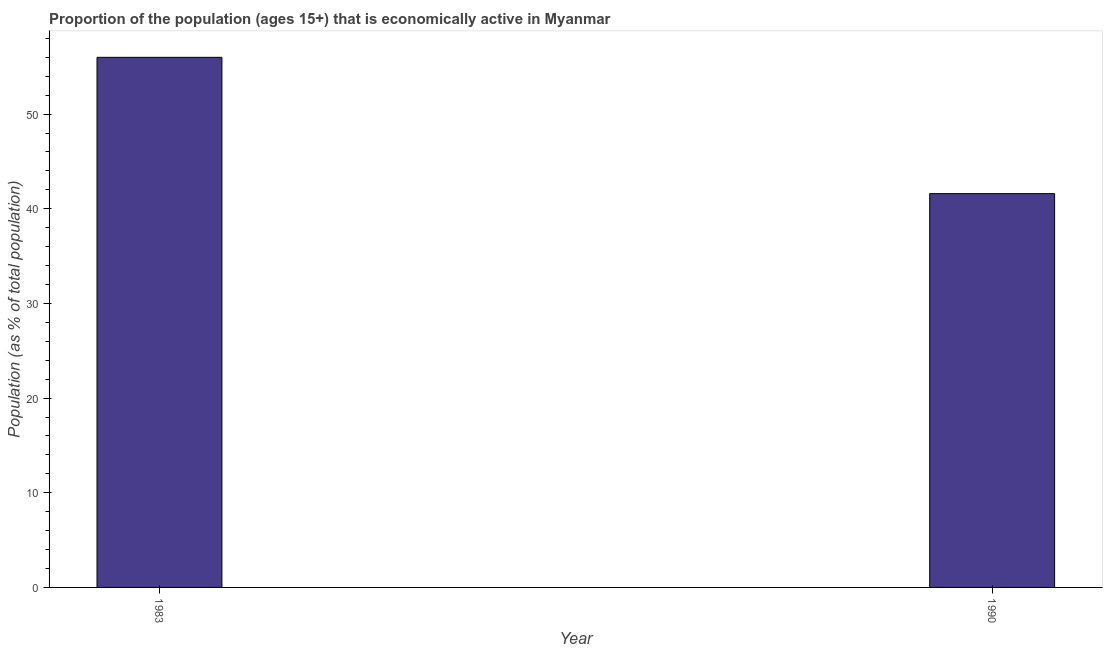Does the graph contain any zero values?
Your response must be concise. No. Does the graph contain grids?
Your answer should be compact. No. What is the title of the graph?
Offer a very short reply. Proportion of the population (ages 15+) that is economically active in Myanmar. What is the label or title of the X-axis?
Keep it short and to the point. Year. What is the label or title of the Y-axis?
Keep it short and to the point. Population (as % of total population). What is the percentage of economically active population in 1990?
Provide a short and direct response. 41.6. Across all years, what is the maximum percentage of economically active population?
Make the answer very short. 56. Across all years, what is the minimum percentage of economically active population?
Keep it short and to the point. 41.6. In which year was the percentage of economically active population maximum?
Offer a very short reply. 1983. What is the sum of the percentage of economically active population?
Ensure brevity in your answer.  97.6. What is the difference between the percentage of economically active population in 1983 and 1990?
Your response must be concise. 14.4. What is the average percentage of economically active population per year?
Offer a very short reply. 48.8. What is the median percentage of economically active population?
Ensure brevity in your answer.  48.8. What is the ratio of the percentage of economically active population in 1983 to that in 1990?
Your answer should be very brief. 1.35. Is the percentage of economically active population in 1983 less than that in 1990?
Offer a terse response. No. How many years are there in the graph?
Ensure brevity in your answer.  2. Are the values on the major ticks of Y-axis written in scientific E-notation?
Your answer should be very brief. No. What is the Population (as % of total population) of 1990?
Make the answer very short. 41.6. What is the ratio of the Population (as % of total population) in 1983 to that in 1990?
Keep it short and to the point. 1.35. 